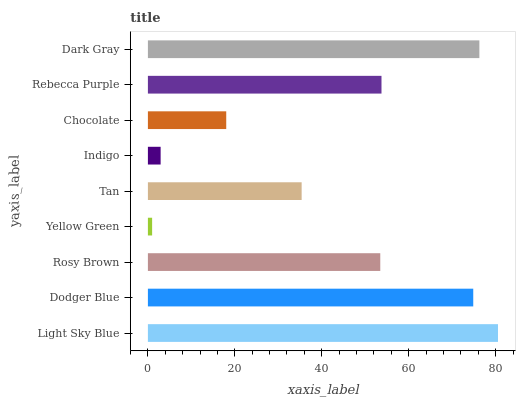Is Yellow Green the minimum?
Answer yes or no. Yes. Is Light Sky Blue the maximum?
Answer yes or no. Yes. Is Dodger Blue the minimum?
Answer yes or no. No. Is Dodger Blue the maximum?
Answer yes or no. No. Is Light Sky Blue greater than Dodger Blue?
Answer yes or no. Yes. Is Dodger Blue less than Light Sky Blue?
Answer yes or no. Yes. Is Dodger Blue greater than Light Sky Blue?
Answer yes or no. No. Is Light Sky Blue less than Dodger Blue?
Answer yes or no. No. Is Rosy Brown the high median?
Answer yes or no. Yes. Is Rosy Brown the low median?
Answer yes or no. Yes. Is Tan the high median?
Answer yes or no. No. Is Chocolate the low median?
Answer yes or no. No. 